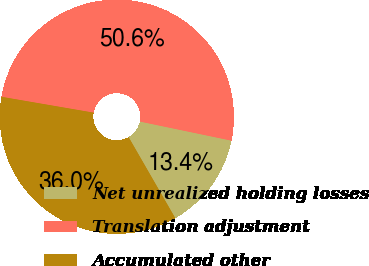Convert chart to OTSL. <chart><loc_0><loc_0><loc_500><loc_500><pie_chart><fcel>Net unrealized holding losses<fcel>Translation adjustment<fcel>Accumulated other<nl><fcel>13.41%<fcel>50.56%<fcel>36.03%<nl></chart> 